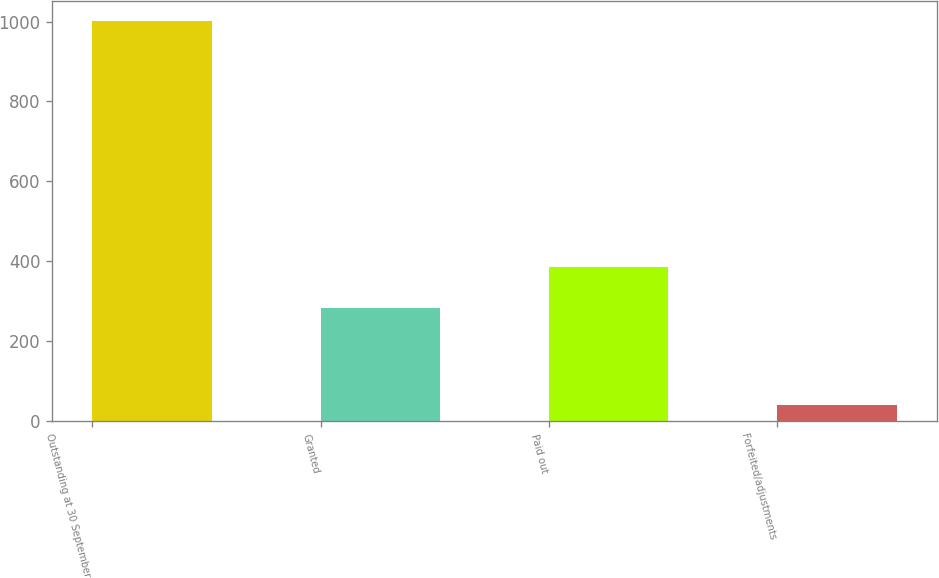<chart> <loc_0><loc_0><loc_500><loc_500><bar_chart><fcel>Outstanding at 30 September<fcel>Granted<fcel>Paid out<fcel>Forfeited/adjustments<nl><fcel>1001<fcel>284<fcel>385.6<fcel>40<nl></chart> 